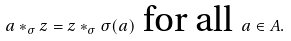Convert formula to latex. <formula><loc_0><loc_0><loc_500><loc_500>a * _ { \sigma } z = z * _ { \sigma } \sigma ( a ) \text { for all } a \in A .</formula> 